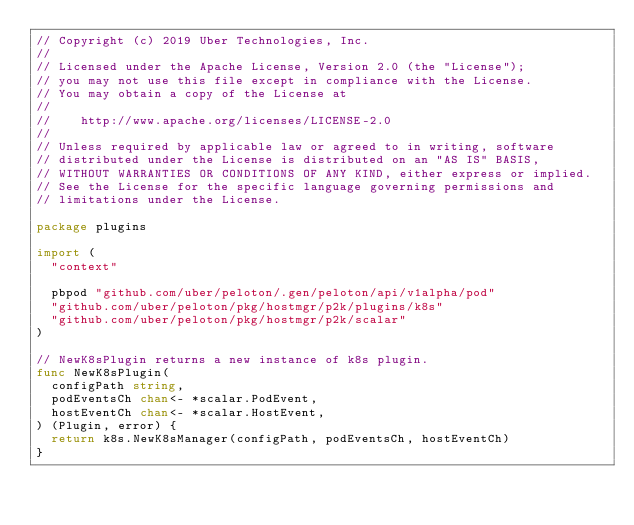Convert code to text. <code><loc_0><loc_0><loc_500><loc_500><_Go_>// Copyright (c) 2019 Uber Technologies, Inc.
//
// Licensed under the Apache License, Version 2.0 (the "License");
// you may not use this file except in compliance with the License.
// You may obtain a copy of the License at
//
//    http://www.apache.org/licenses/LICENSE-2.0
//
// Unless required by applicable law or agreed to in writing, software
// distributed under the License is distributed on an "AS IS" BASIS,
// WITHOUT WARRANTIES OR CONDITIONS OF ANY KIND, either express or implied.
// See the License for the specific language governing permissions and
// limitations under the License.

package plugins

import (
	"context"

	pbpod "github.com/uber/peloton/.gen/peloton/api/v1alpha/pod"
	"github.com/uber/peloton/pkg/hostmgr/p2k/plugins/k8s"
	"github.com/uber/peloton/pkg/hostmgr/p2k/scalar"
)

// NewK8sPlugin returns a new instance of k8s plugin.
func NewK8sPlugin(
	configPath string,
	podEventsCh chan<- *scalar.PodEvent,
	hostEventCh chan<- *scalar.HostEvent,
) (Plugin, error) {
	return k8s.NewK8sManager(configPath, podEventsCh, hostEventCh)
}
</code> 